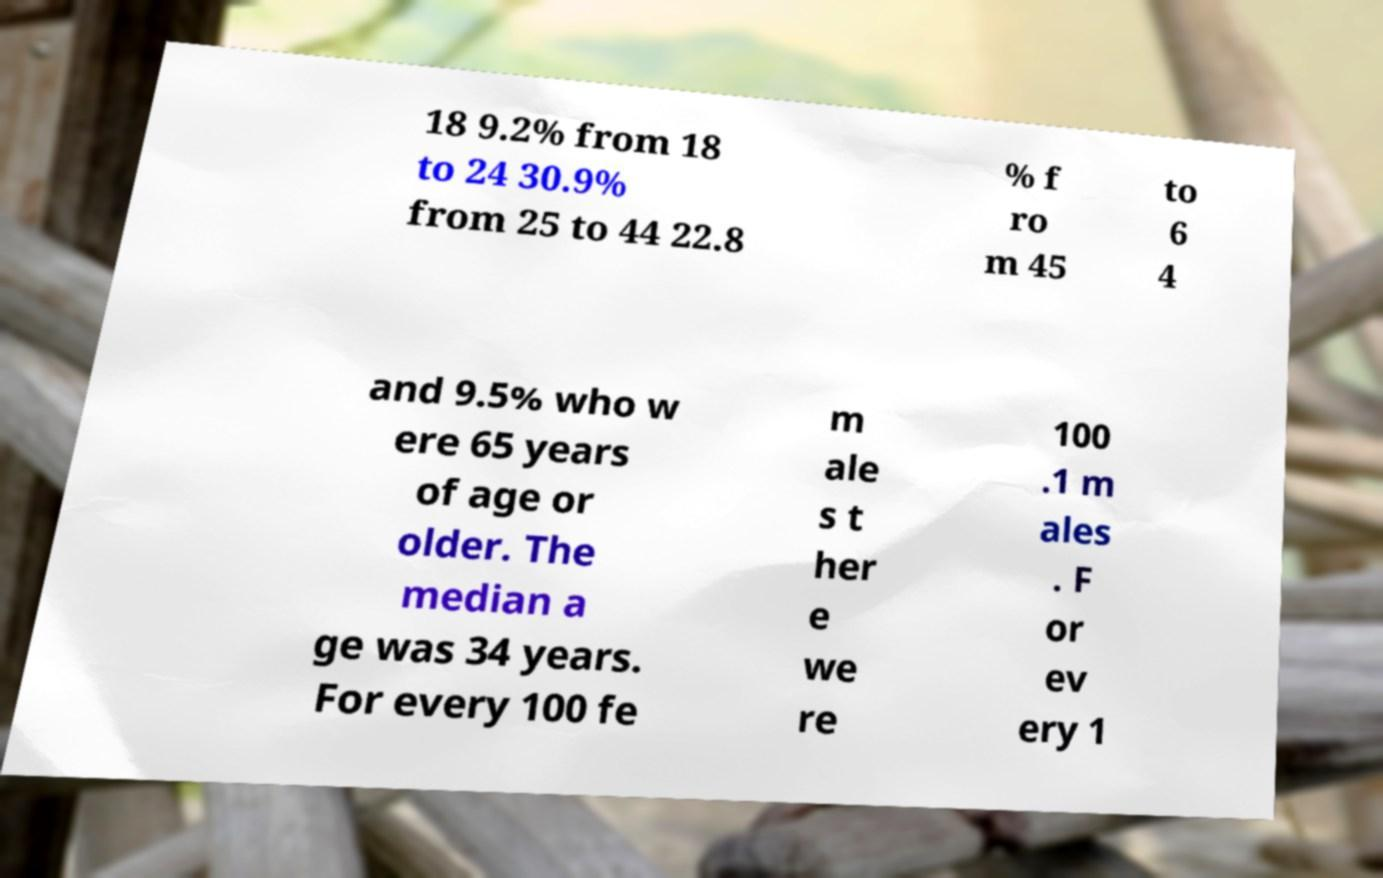Please identify and transcribe the text found in this image. 18 9.2% from 18 to 24 30.9% from 25 to 44 22.8 % f ro m 45 to 6 4 and 9.5% who w ere 65 years of age or older. The median a ge was 34 years. For every 100 fe m ale s t her e we re 100 .1 m ales . F or ev ery 1 